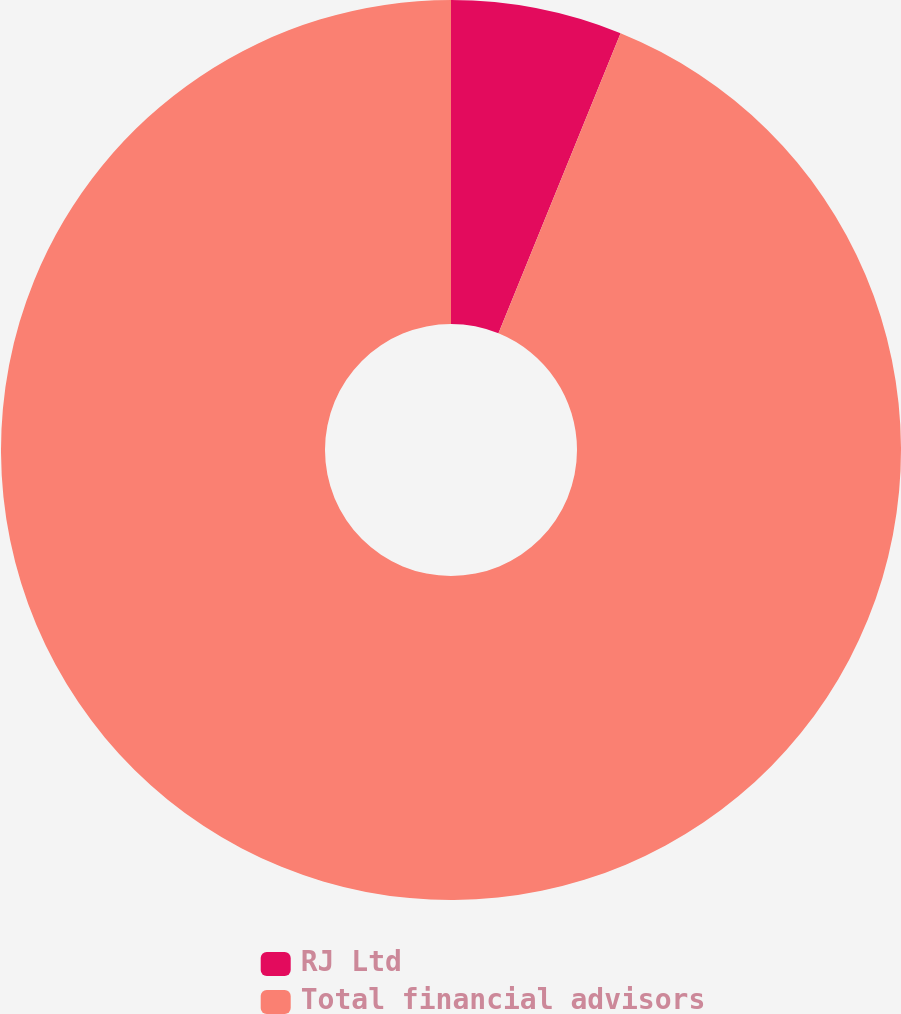<chart> <loc_0><loc_0><loc_500><loc_500><pie_chart><fcel>RJ Ltd<fcel>Total financial advisors<nl><fcel>6.15%<fcel>93.85%<nl></chart> 